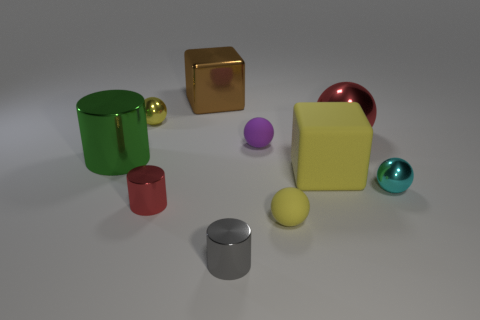Do the cylinder that is to the right of the brown cube and the brown object have the same size?
Your response must be concise. No. Is there any other thing that has the same color as the large matte thing?
Offer a very short reply. Yes. What shape is the brown shiny thing?
Make the answer very short. Cube. How many metallic things are both in front of the purple sphere and on the right side of the tiny gray cylinder?
Provide a succinct answer. 1. Does the shiny cube have the same color as the big cylinder?
Your response must be concise. No. There is a large green object that is the same shape as the gray object; what is it made of?
Offer a terse response. Metal. Is there any other thing that has the same material as the large yellow block?
Your response must be concise. Yes. Are there the same number of tiny purple balls that are behind the purple sphere and tiny purple balls that are right of the tiny red object?
Offer a terse response. No. Is the red sphere made of the same material as the large green cylinder?
Your response must be concise. Yes. What number of yellow things are either big matte blocks or large matte balls?
Make the answer very short. 1. 